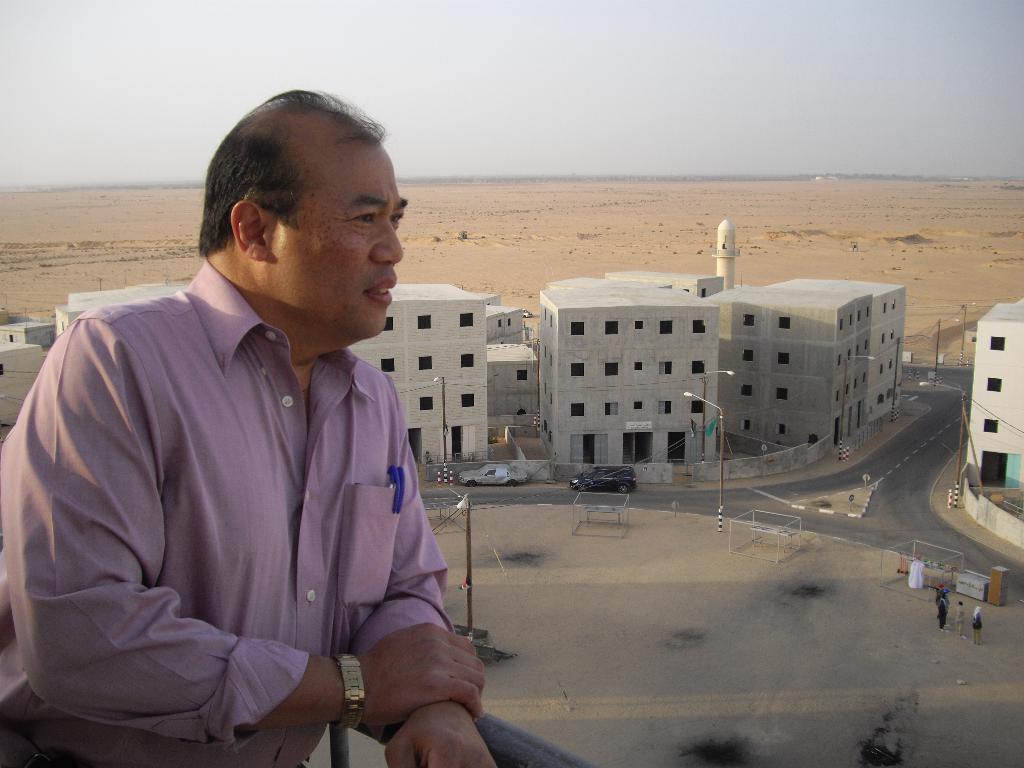In one or two sentences, can you explain what this image depicts? In this image, we can see a person near the rod railing. In the background, there are buildings, roads, street lights, poles, wires, vehicles, walls, windows, people, some objects and the sky. 